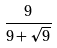Convert formula to latex. <formula><loc_0><loc_0><loc_500><loc_500>\frac { 9 } { 9 + \sqrt { 9 } }</formula> 